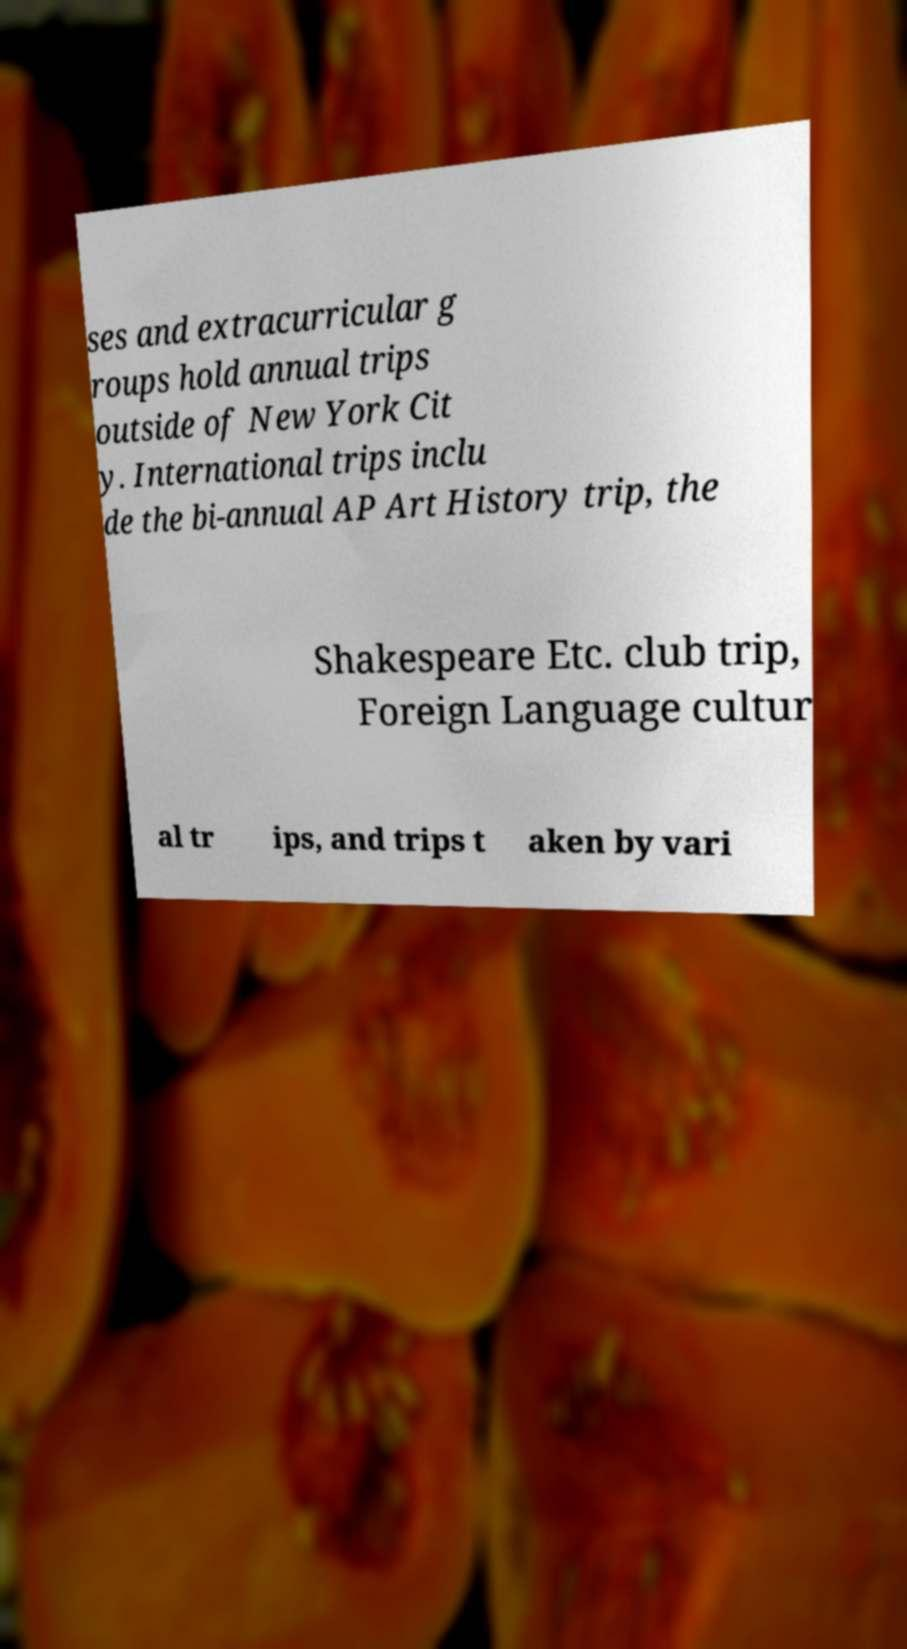Can you read and provide the text displayed in the image?This photo seems to have some interesting text. Can you extract and type it out for me? ses and extracurricular g roups hold annual trips outside of New York Cit y. International trips inclu de the bi-annual AP Art History trip, the Shakespeare Etc. club trip, Foreign Language cultur al tr ips, and trips t aken by vari 